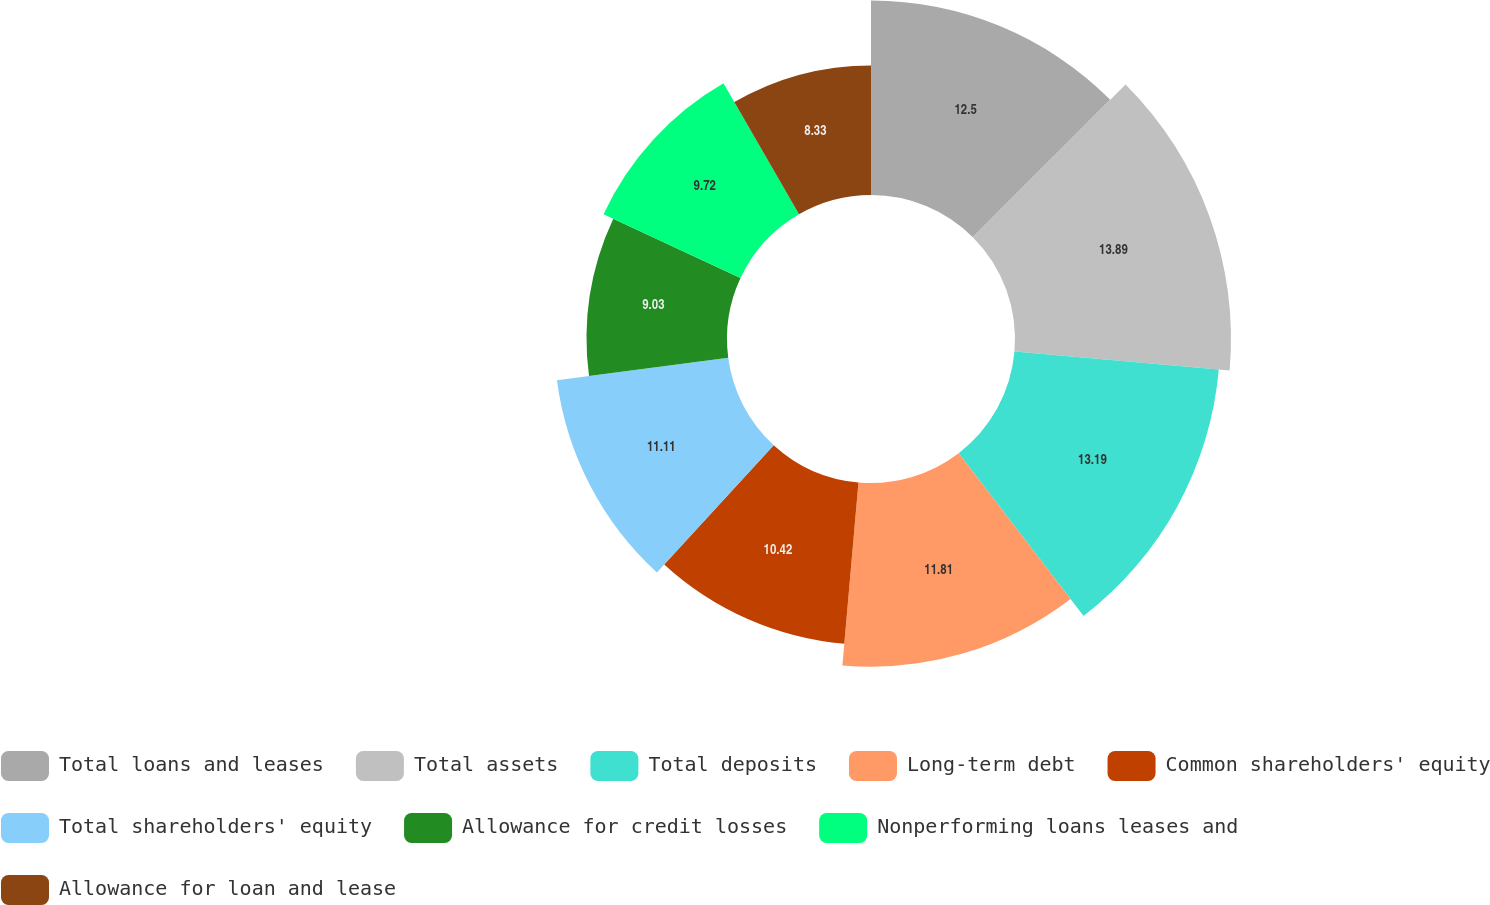Convert chart to OTSL. <chart><loc_0><loc_0><loc_500><loc_500><pie_chart><fcel>Total loans and leases<fcel>Total assets<fcel>Total deposits<fcel>Long-term debt<fcel>Common shareholders' equity<fcel>Total shareholders' equity<fcel>Allowance for credit losses<fcel>Nonperforming loans leases and<fcel>Allowance for loan and lease<nl><fcel>12.5%<fcel>13.89%<fcel>13.19%<fcel>11.81%<fcel>10.42%<fcel>11.11%<fcel>9.03%<fcel>9.72%<fcel>8.33%<nl></chart> 